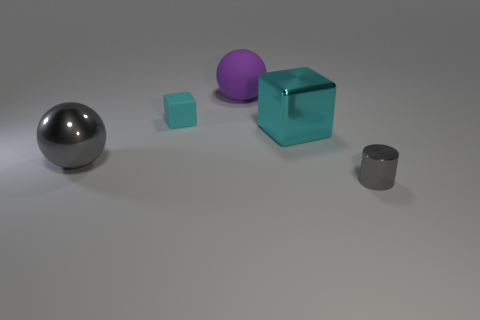Add 4 small rubber blocks. How many objects exist? 9 Subtract all cubes. How many objects are left? 3 Add 1 cyan cubes. How many cyan cubes are left? 3 Add 5 cyan rubber cylinders. How many cyan rubber cylinders exist? 5 Subtract 1 gray cylinders. How many objects are left? 4 Subtract all large purple rubber spheres. Subtract all large objects. How many objects are left? 1 